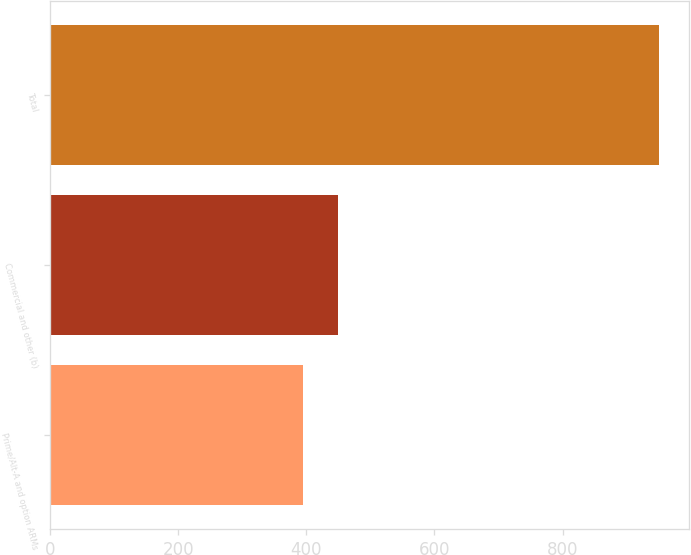Convert chart. <chart><loc_0><loc_0><loc_500><loc_500><bar_chart><fcel>Prime/Alt-A and option ARMs<fcel>Commercial and other (b)<fcel>Total<nl><fcel>394<fcel>449.6<fcel>950<nl></chart> 